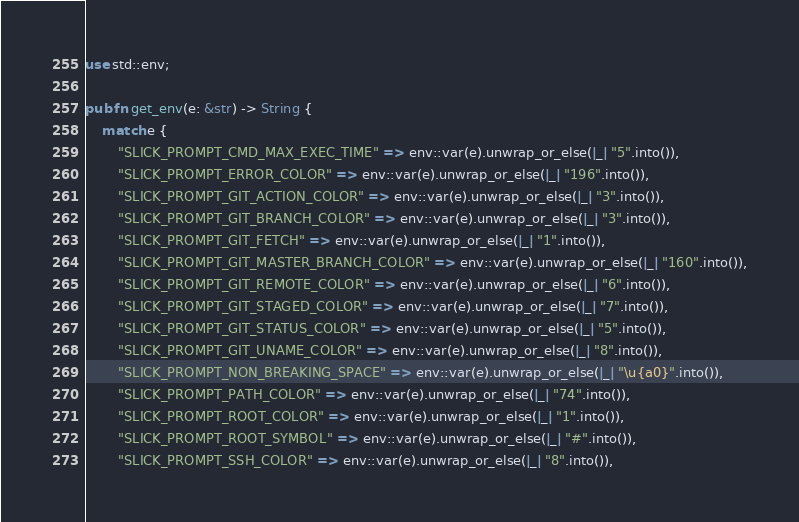<code> <loc_0><loc_0><loc_500><loc_500><_Rust_>use std::env;

pub fn get_env(e: &str) -> String {
    match e {
        "SLICK_PROMPT_CMD_MAX_EXEC_TIME" => env::var(e).unwrap_or_else(|_| "5".into()),
        "SLICK_PROMPT_ERROR_COLOR" => env::var(e).unwrap_or_else(|_| "196".into()),
        "SLICK_PROMPT_GIT_ACTION_COLOR" => env::var(e).unwrap_or_else(|_| "3".into()),
        "SLICK_PROMPT_GIT_BRANCH_COLOR" => env::var(e).unwrap_or_else(|_| "3".into()),
        "SLICK_PROMPT_GIT_FETCH" => env::var(e).unwrap_or_else(|_| "1".into()),
        "SLICK_PROMPT_GIT_MASTER_BRANCH_COLOR" => env::var(e).unwrap_or_else(|_| "160".into()),
        "SLICK_PROMPT_GIT_REMOTE_COLOR" => env::var(e).unwrap_or_else(|_| "6".into()),
        "SLICK_PROMPT_GIT_STAGED_COLOR" => env::var(e).unwrap_or_else(|_| "7".into()),
        "SLICK_PROMPT_GIT_STATUS_COLOR" => env::var(e).unwrap_or_else(|_| "5".into()),
        "SLICK_PROMPT_GIT_UNAME_COLOR" => env::var(e).unwrap_or_else(|_| "8".into()),
        "SLICK_PROMPT_NON_BREAKING_SPACE" => env::var(e).unwrap_or_else(|_| "\u{a0}".into()),
        "SLICK_PROMPT_PATH_COLOR" => env::var(e).unwrap_or_else(|_| "74".into()),
        "SLICK_PROMPT_ROOT_COLOR" => env::var(e).unwrap_or_else(|_| "1".into()),
        "SLICK_PROMPT_ROOT_SYMBOL" => env::var(e).unwrap_or_else(|_| "#".into()),
        "SLICK_PROMPT_SSH_COLOR" => env::var(e).unwrap_or_else(|_| "8".into()),</code> 